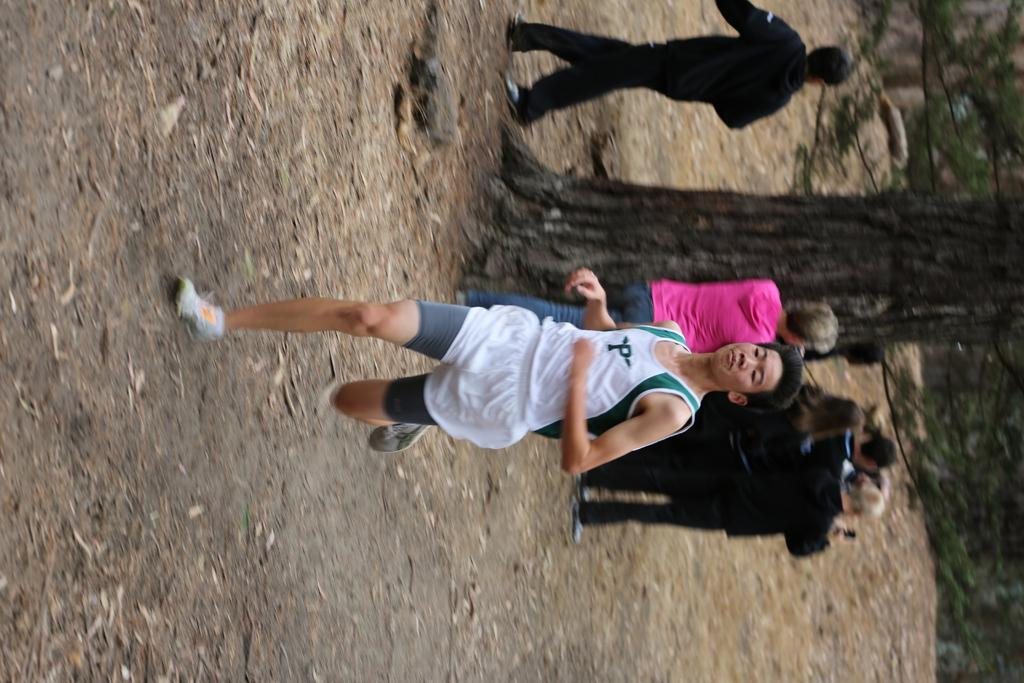What are the people in the image doing? There are people standing, walking, and running in the image. Can you describe the background of the image? There are trees in the background of the image. What type of feather can be seen falling from the sky in the image? There is no feather falling from the sky in the image. Is there a drain visible in the image? No, there is no drain present in the image. 